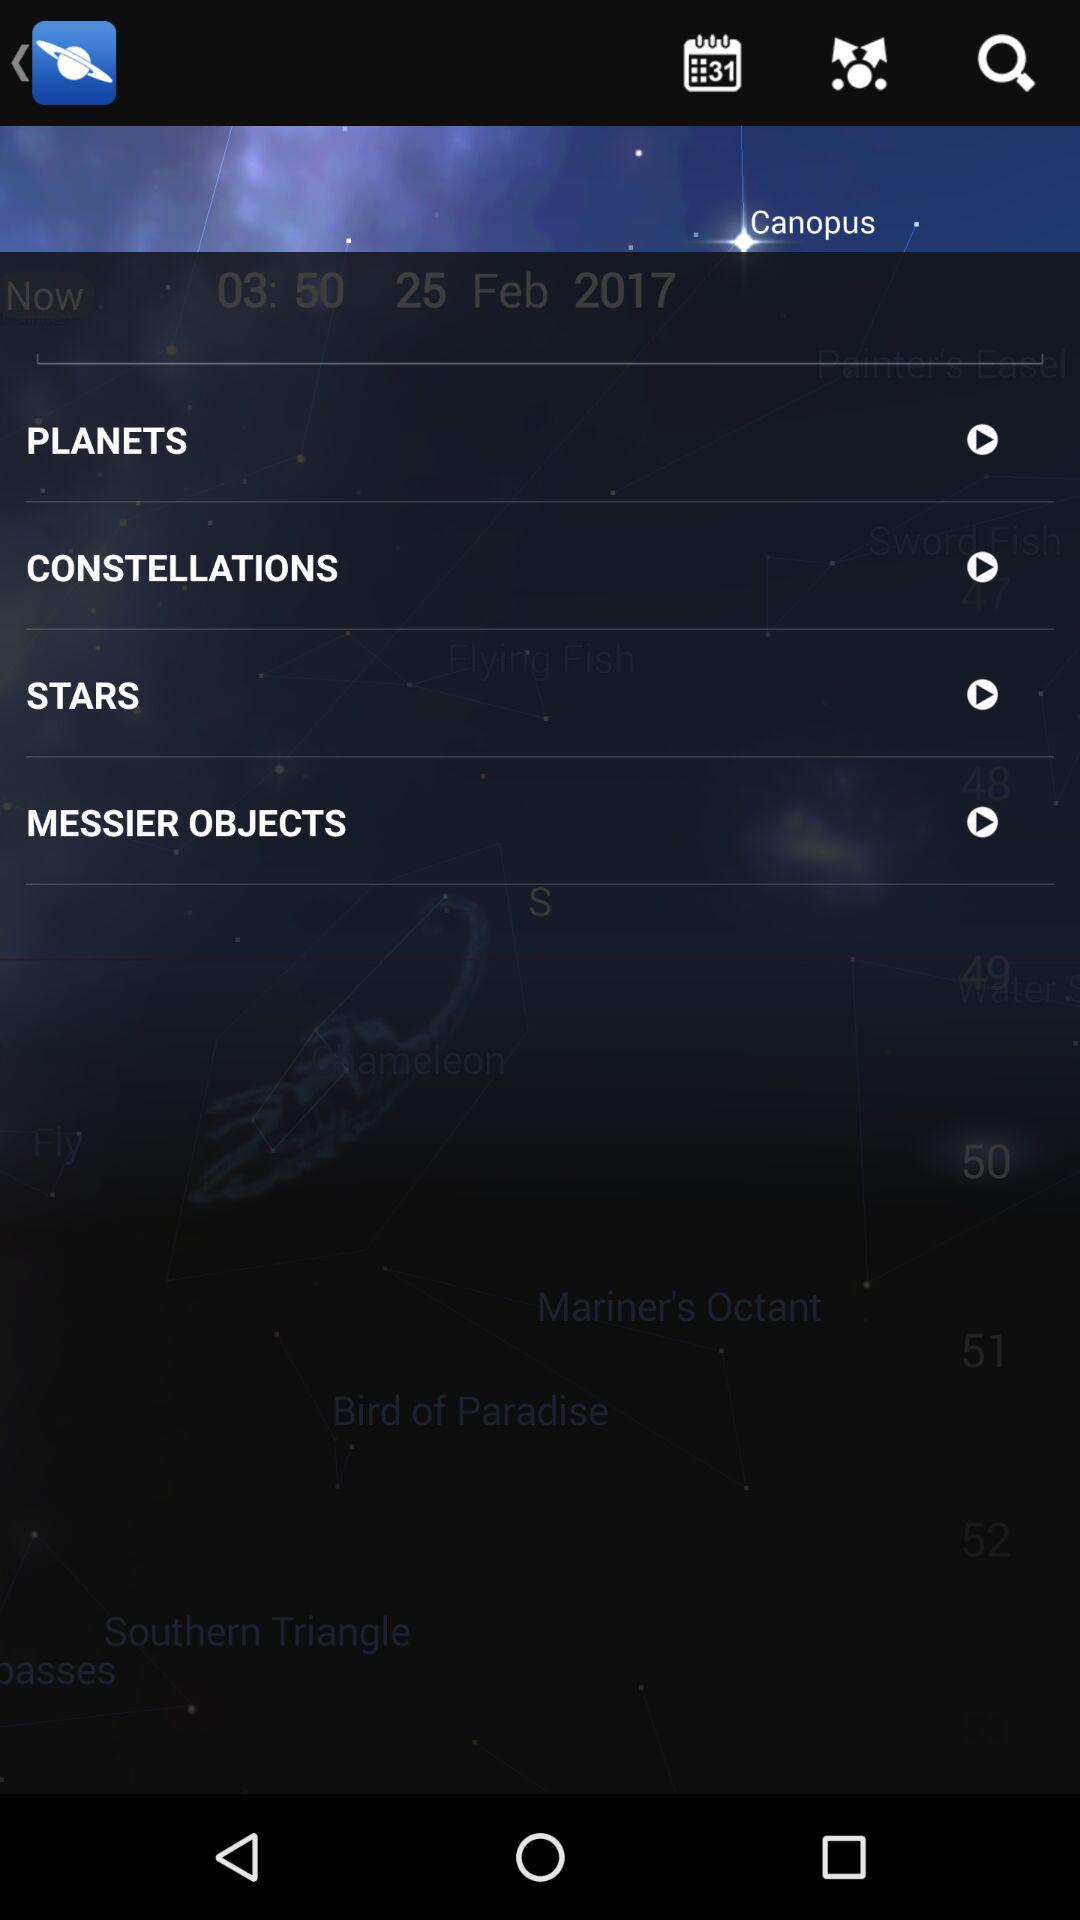Which date is mentioned? The mentioned date is February 25, 2017. 